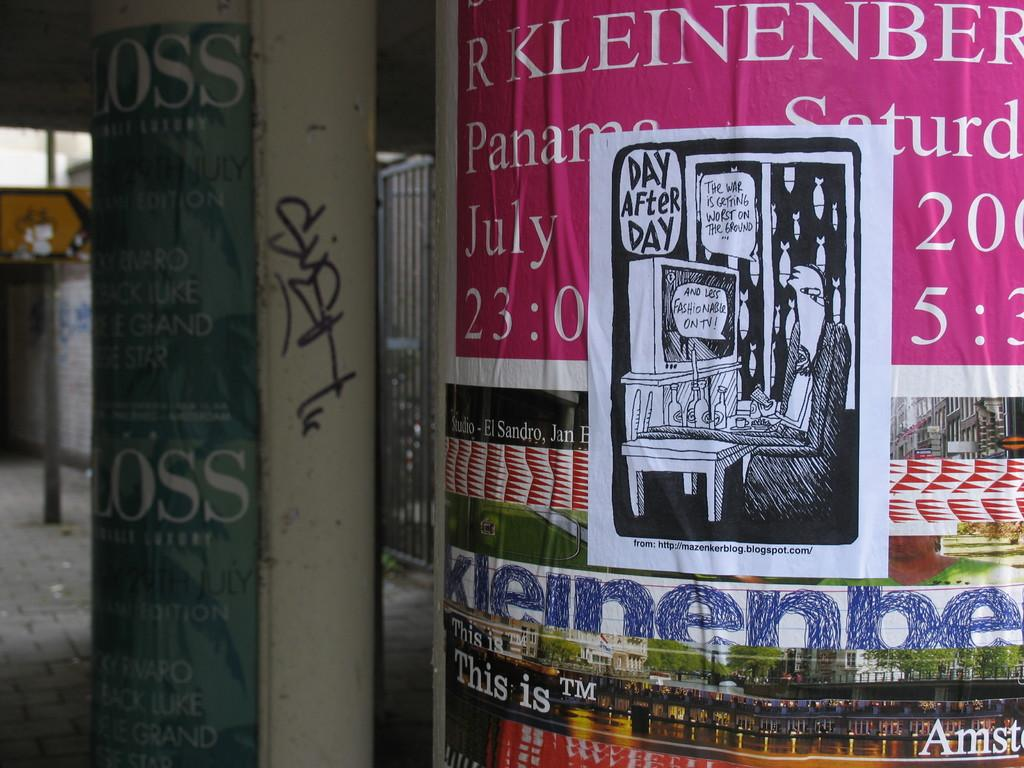<image>
Provide a brief description of the given image. A poster for R Kleinenberg with a graffiti sticker slapped on the middle of it. 